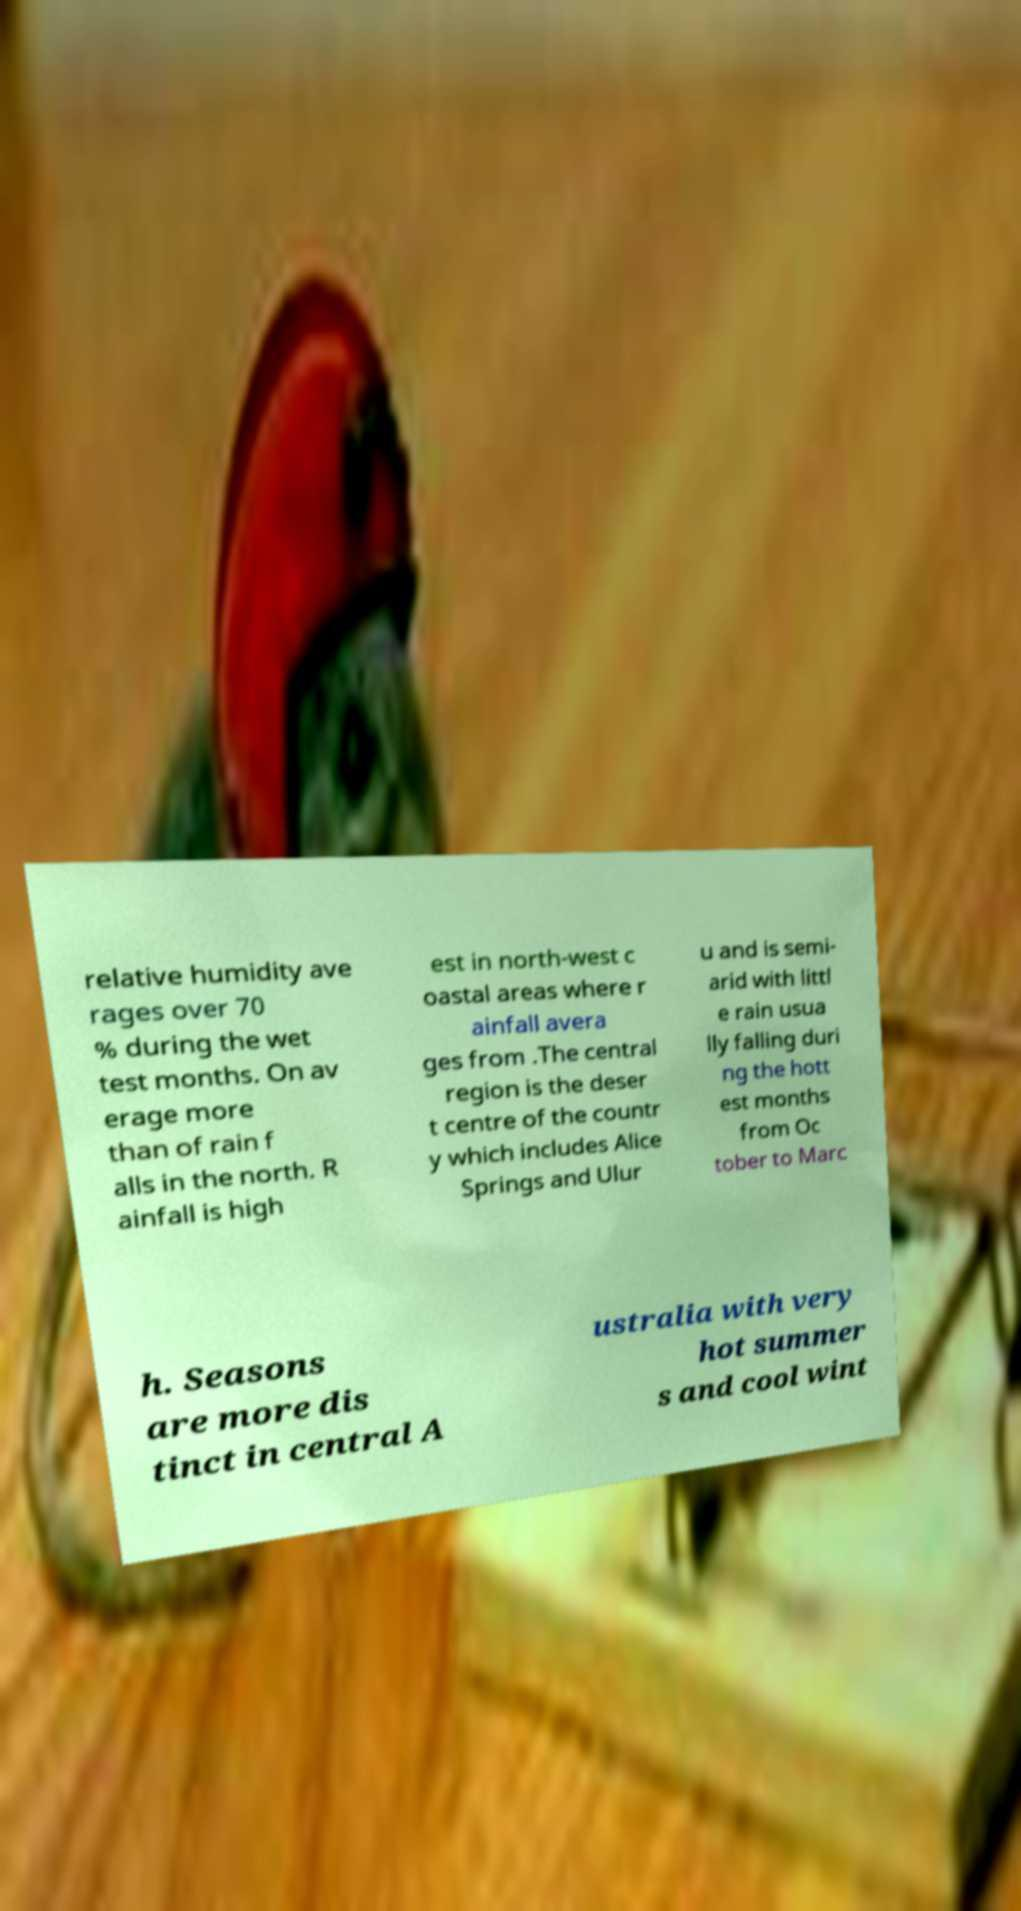Can you read and provide the text displayed in the image?This photo seems to have some interesting text. Can you extract and type it out for me? relative humidity ave rages over 70 % during the wet test months. On av erage more than of rain f alls in the north. R ainfall is high est in north-west c oastal areas where r ainfall avera ges from .The central region is the deser t centre of the countr y which includes Alice Springs and Ulur u and is semi- arid with littl e rain usua lly falling duri ng the hott est months from Oc tober to Marc h. Seasons are more dis tinct in central A ustralia with very hot summer s and cool wint 